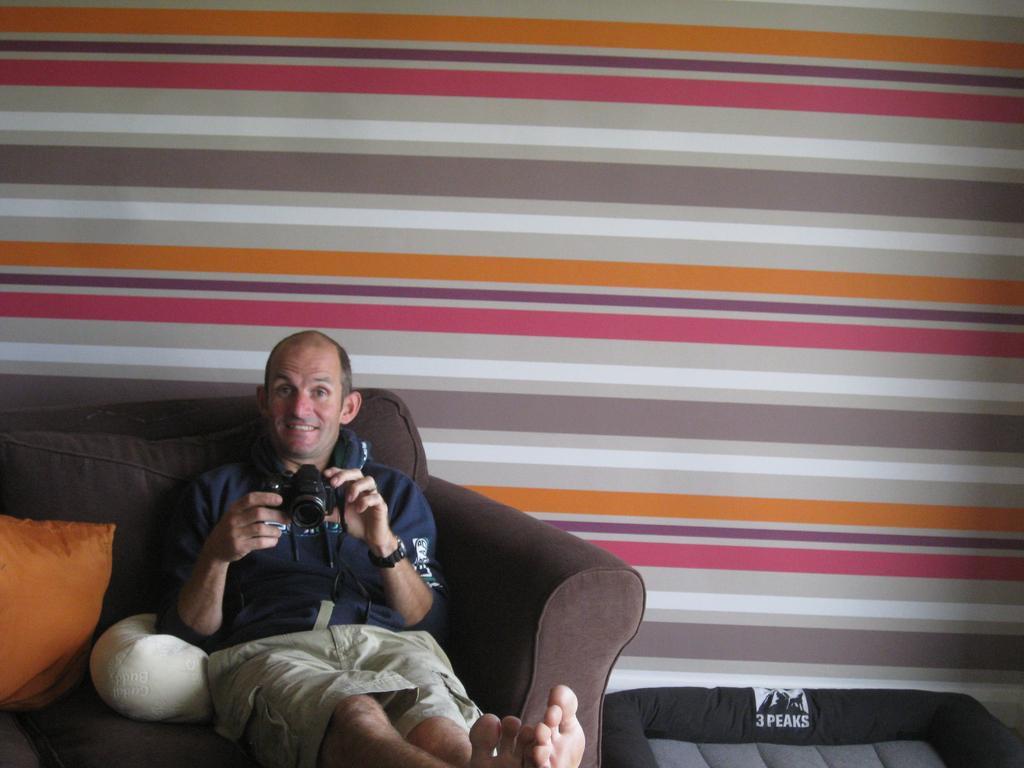How would you summarize this image in a sentence or two? In this image there is a person sitting on the sofa and holding a camera. There are gold and white color pillows on the sofa. 